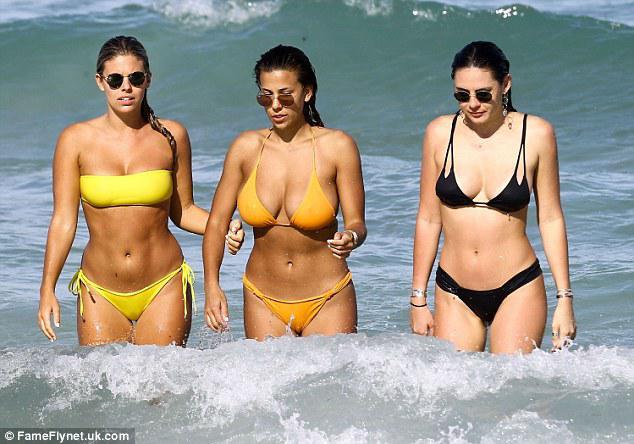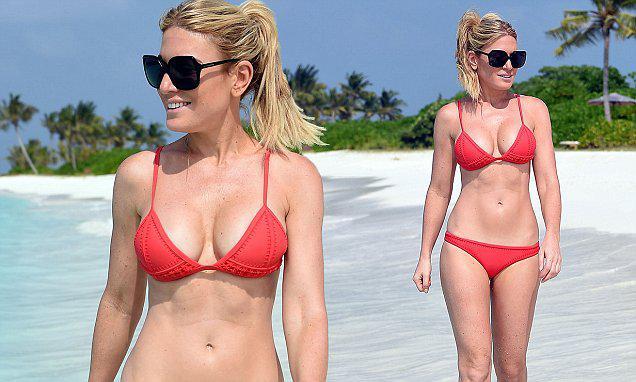The first image is the image on the left, the second image is the image on the right. Analyze the images presented: Is the assertion "There is at least one pregnant woman." valid? Answer yes or no. No. The first image is the image on the left, the second image is the image on the right. Evaluate the accuracy of this statement regarding the images: "Right image shows three bikini-wearing women standing close together.". Is it true? Answer yes or no. No. 